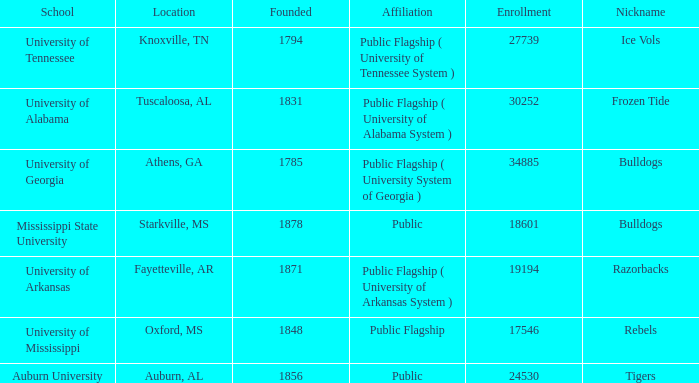What is the maximum enrollment of the schools? 34885.0. 